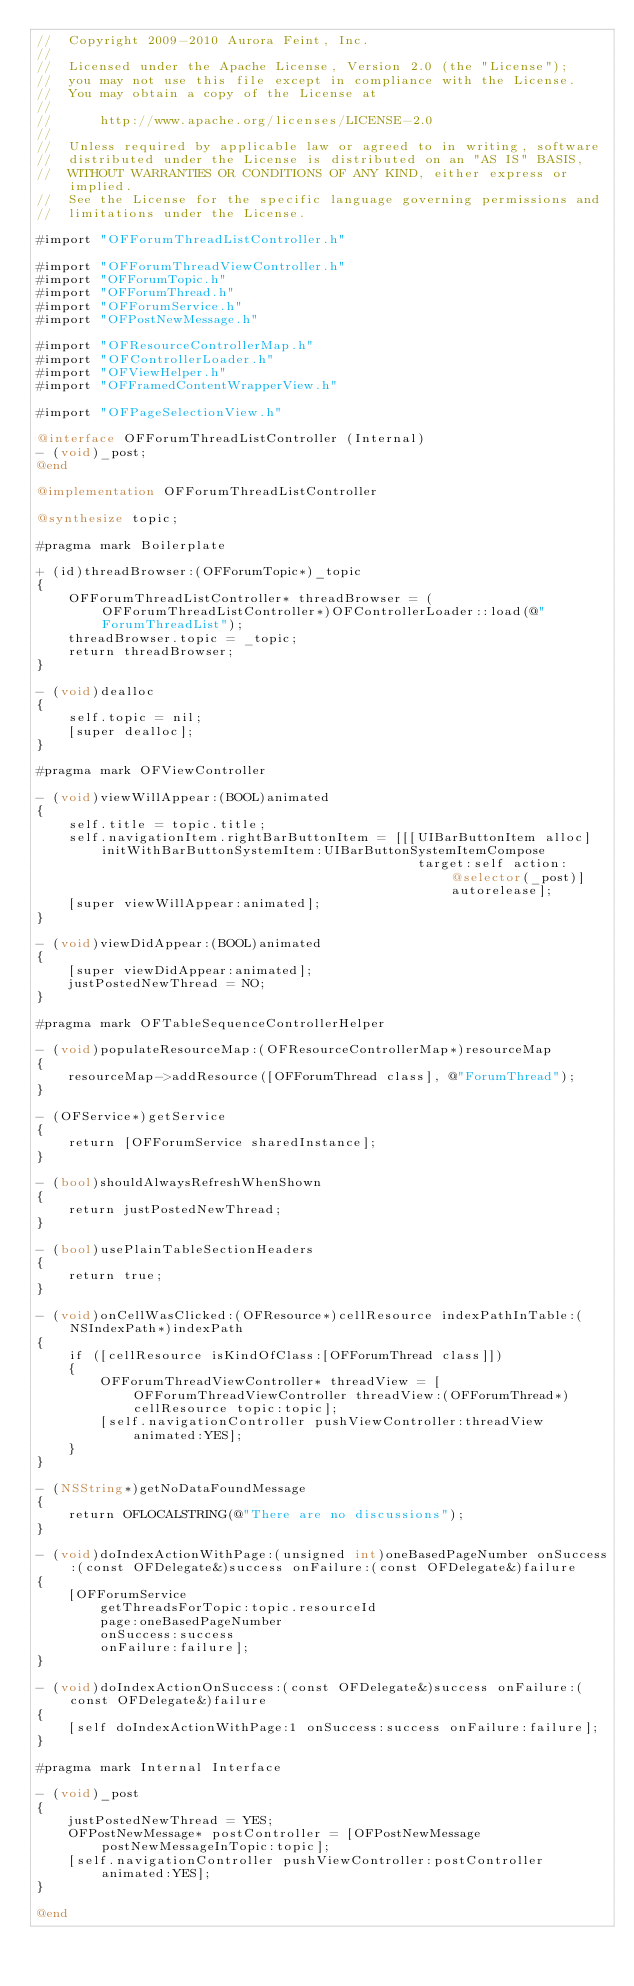Convert code to text. <code><loc_0><loc_0><loc_500><loc_500><_ObjectiveC_>//  Copyright 2009-2010 Aurora Feint, Inc.
// 
//  Licensed under the Apache License, Version 2.0 (the "License");
//  you may not use this file except in compliance with the License.
//  You may obtain a copy of the License at
//  
//  	http://www.apache.org/licenses/LICENSE-2.0
//  	
//  Unless required by applicable law or agreed to in writing, software
//  distributed under the License is distributed on an "AS IS" BASIS,
//  WITHOUT WARRANTIES OR CONDITIONS OF ANY KIND, either express or implied.
//  See the License for the specific language governing permissions and
//  limitations under the License.

#import "OFForumThreadListController.h"

#import "OFForumThreadViewController.h"
#import "OFForumTopic.h"
#import "OFForumThread.h"
#import "OFForumService.h"
#import "OFPostNewMessage.h"

#import "OFResourceControllerMap.h"
#import "OFControllerLoader.h"
#import "OFViewHelper.h"
#import "OFFramedContentWrapperView.h"

#import "OFPageSelectionView.h"

@interface OFForumThreadListController (Internal)
- (void)_post;
@end

@implementation OFForumThreadListController

@synthesize topic;

#pragma mark Boilerplate

+ (id)threadBrowser:(OFForumTopic*)_topic
{
	OFForumThreadListController* threadBrowser = (OFForumThreadListController*)OFControllerLoader::load(@"ForumThreadList");
	threadBrowser.topic = _topic;
	return threadBrowser;
}

- (void)dealloc
{
	self.topic = nil;
	[super dealloc];
}

#pragma mark OFViewController

- (void)viewWillAppear:(BOOL)animated
{
	self.title = topic.title;
	self.navigationItem.rightBarButtonItem = [[[UIBarButtonItem alloc] initWithBarButtonSystemItem:UIBarButtonSystemItemCompose 
												target:self action:@selector(_post)] autorelease];
	[super viewWillAppear:animated];
}

- (void)viewDidAppear:(BOOL)animated
{
	[super viewDidAppear:animated];
	justPostedNewThread = NO;
}

#pragma mark OFTableSequenceControllerHelper

- (void)populateResourceMap:(OFResourceControllerMap*)resourceMap
{
	resourceMap->addResource([OFForumThread class], @"ForumThread");
}

- (OFService*)getService
{
	return [OFForumService sharedInstance];
}

- (bool)shouldAlwaysRefreshWhenShown
{
	return justPostedNewThread;
}

- (bool)usePlainTableSectionHeaders
{
	return true;
}

- (void)onCellWasClicked:(OFResource*)cellResource indexPathInTable:(NSIndexPath*)indexPath
{
	if ([cellResource isKindOfClass:[OFForumThread class]])
	{
		OFForumThreadViewController* threadView = [OFForumThreadViewController threadView:(OFForumThread*)cellResource topic:topic];
		[self.navigationController pushViewController:threadView animated:YES];
	}
}

- (NSString*)getNoDataFoundMessage
{
	return OFLOCALSTRING(@"There are no discussions");
}

- (void)doIndexActionWithPage:(unsigned int)oneBasedPageNumber onSuccess:(const OFDelegate&)success onFailure:(const OFDelegate&)failure
{
	[OFForumService
		getThreadsForTopic:topic.resourceId 
		page:oneBasedPageNumber 
		onSuccess:success 
		onFailure:failure];
}

- (void)doIndexActionOnSuccess:(const OFDelegate&)success onFailure:(const OFDelegate&)failure
{
	[self doIndexActionWithPage:1 onSuccess:success onFailure:failure];
}

#pragma mark Internal Interface

- (void)_post
{
	justPostedNewThread = YES;
	OFPostNewMessage* postController = [OFPostNewMessage postNewMessageInTopic:topic];
	[self.navigationController pushViewController:postController animated:YES];
}

@end
</code> 